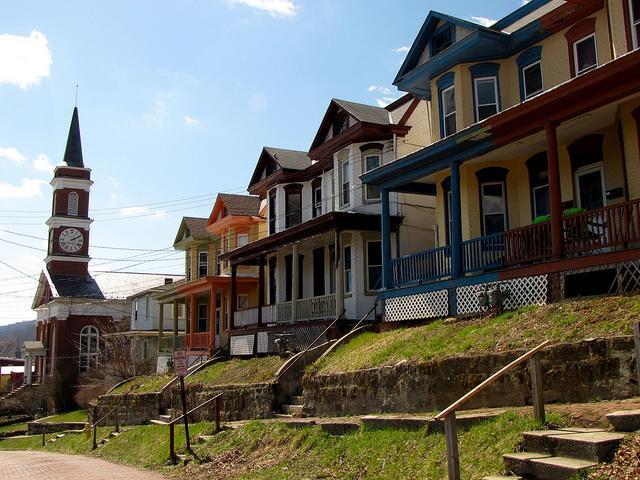How many clocks are on the building?
Give a very brief answer. 1. 